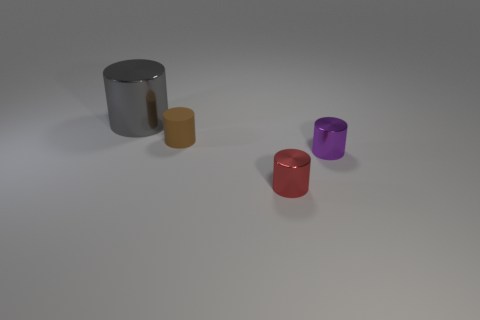Subtract all small cylinders. How many cylinders are left? 1 Add 3 small red things. How many objects exist? 7 Subtract all brown cylinders. How many cylinders are left? 3 Add 4 small brown rubber blocks. How many small brown rubber blocks exist? 4 Subtract 0 gray blocks. How many objects are left? 4 Subtract all green cylinders. Subtract all yellow balls. How many cylinders are left? 4 Subtract all big yellow objects. Subtract all small red things. How many objects are left? 3 Add 4 large gray cylinders. How many large gray cylinders are left? 5 